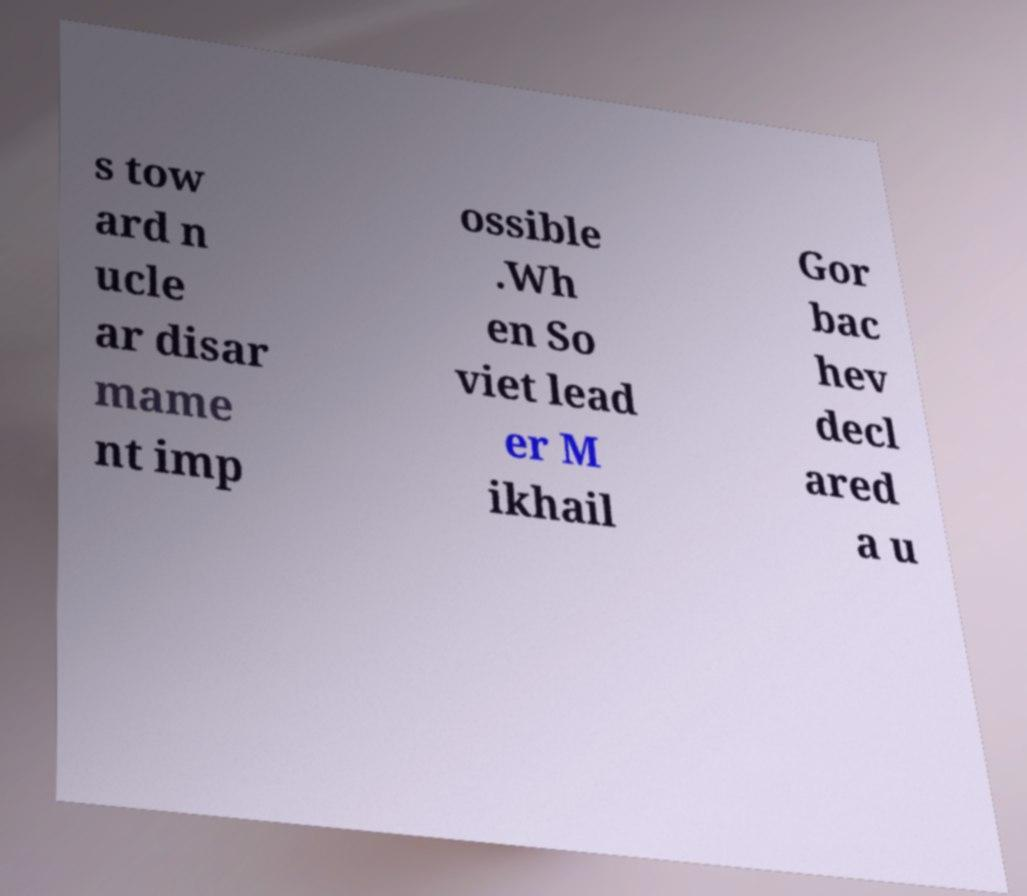There's text embedded in this image that I need extracted. Can you transcribe it verbatim? s tow ard n ucle ar disar mame nt imp ossible .Wh en So viet lead er M ikhail Gor bac hev decl ared a u 